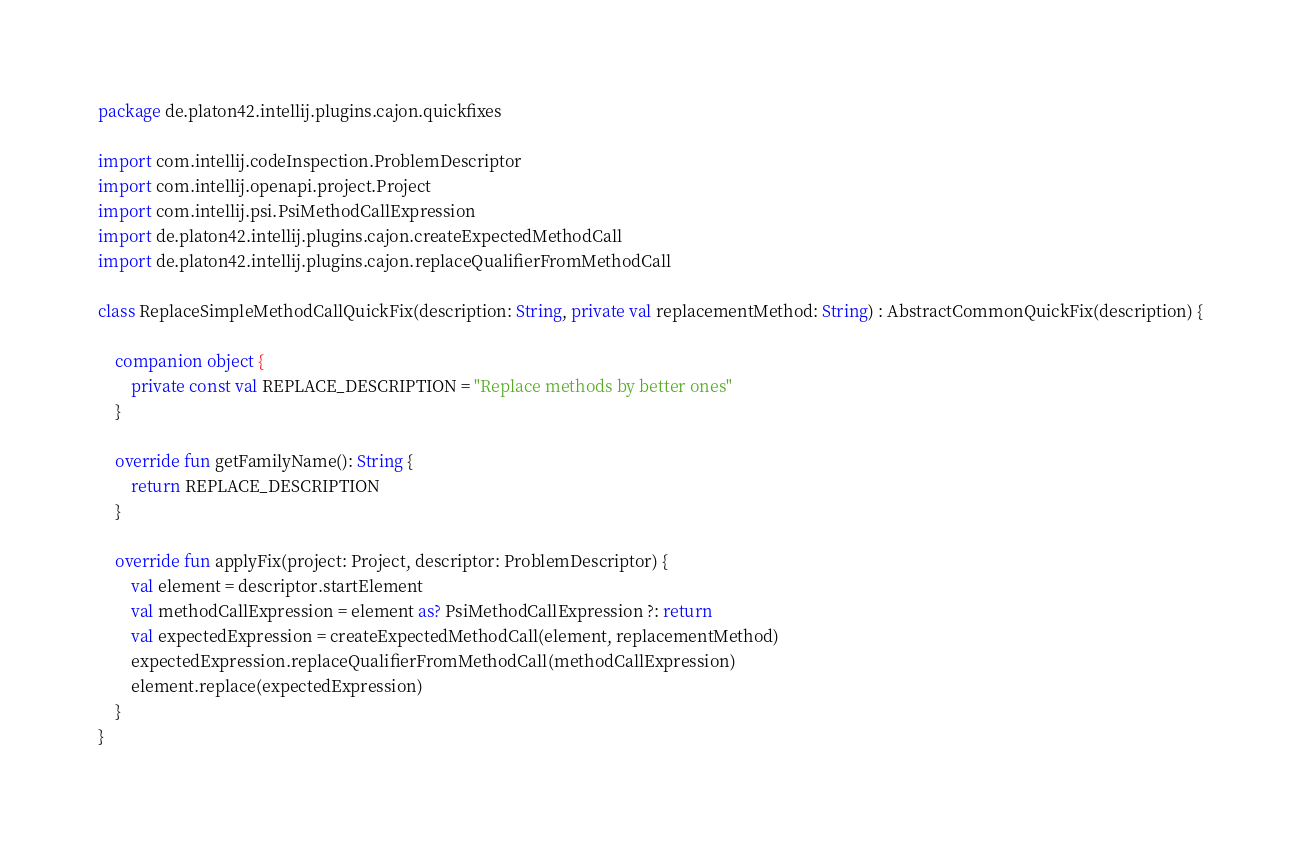Convert code to text. <code><loc_0><loc_0><loc_500><loc_500><_Kotlin_>package de.platon42.intellij.plugins.cajon.quickfixes

import com.intellij.codeInspection.ProblemDescriptor
import com.intellij.openapi.project.Project
import com.intellij.psi.PsiMethodCallExpression
import de.platon42.intellij.plugins.cajon.createExpectedMethodCall
import de.platon42.intellij.plugins.cajon.replaceQualifierFromMethodCall

class ReplaceSimpleMethodCallQuickFix(description: String, private val replacementMethod: String) : AbstractCommonQuickFix(description) {

    companion object {
        private const val REPLACE_DESCRIPTION = "Replace methods by better ones"
    }

    override fun getFamilyName(): String {
        return REPLACE_DESCRIPTION
    }

    override fun applyFix(project: Project, descriptor: ProblemDescriptor) {
        val element = descriptor.startElement
        val methodCallExpression = element as? PsiMethodCallExpression ?: return
        val expectedExpression = createExpectedMethodCall(element, replacementMethod)
        expectedExpression.replaceQualifierFromMethodCall(methodCallExpression)
        element.replace(expectedExpression)
    }
}</code> 